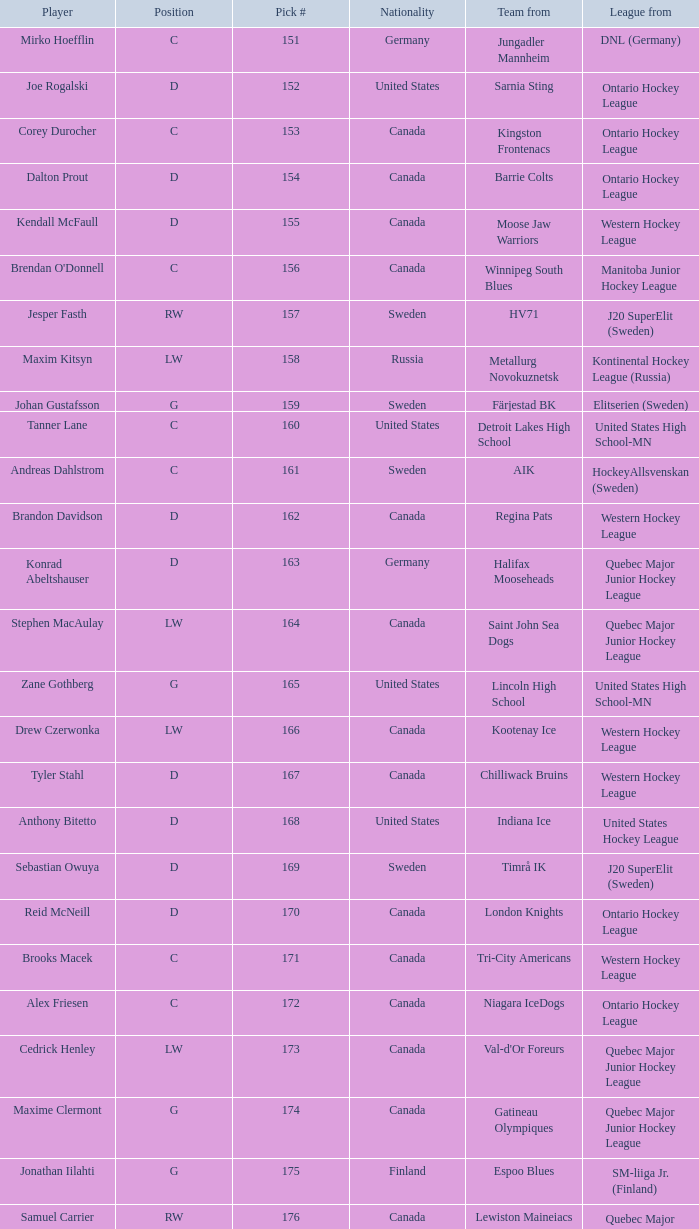What is the total pick # for the D position from a team from Chilliwack Bruins? 167.0. 